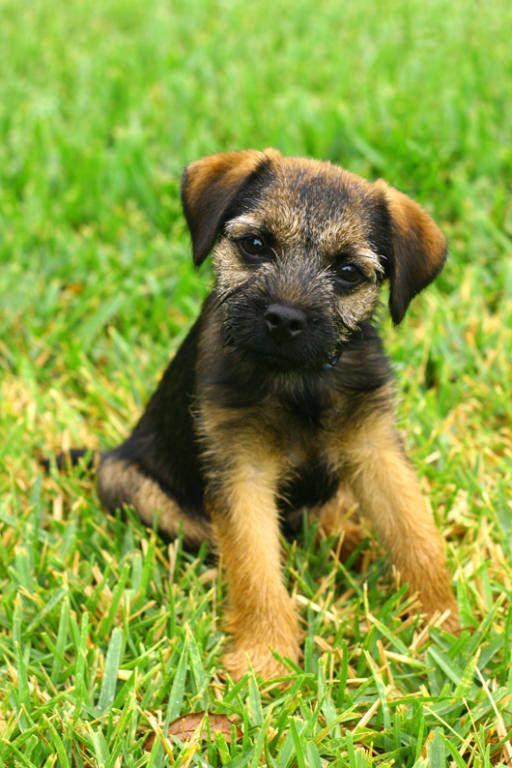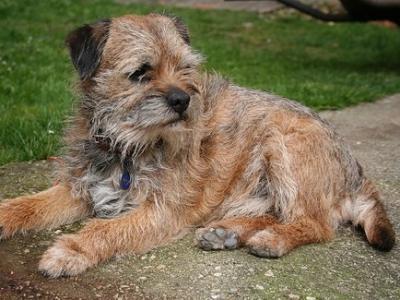The first image is the image on the left, the second image is the image on the right. For the images displayed, is the sentence "In the image to the right, all dogs are standing up." factually correct? Answer yes or no. No. 